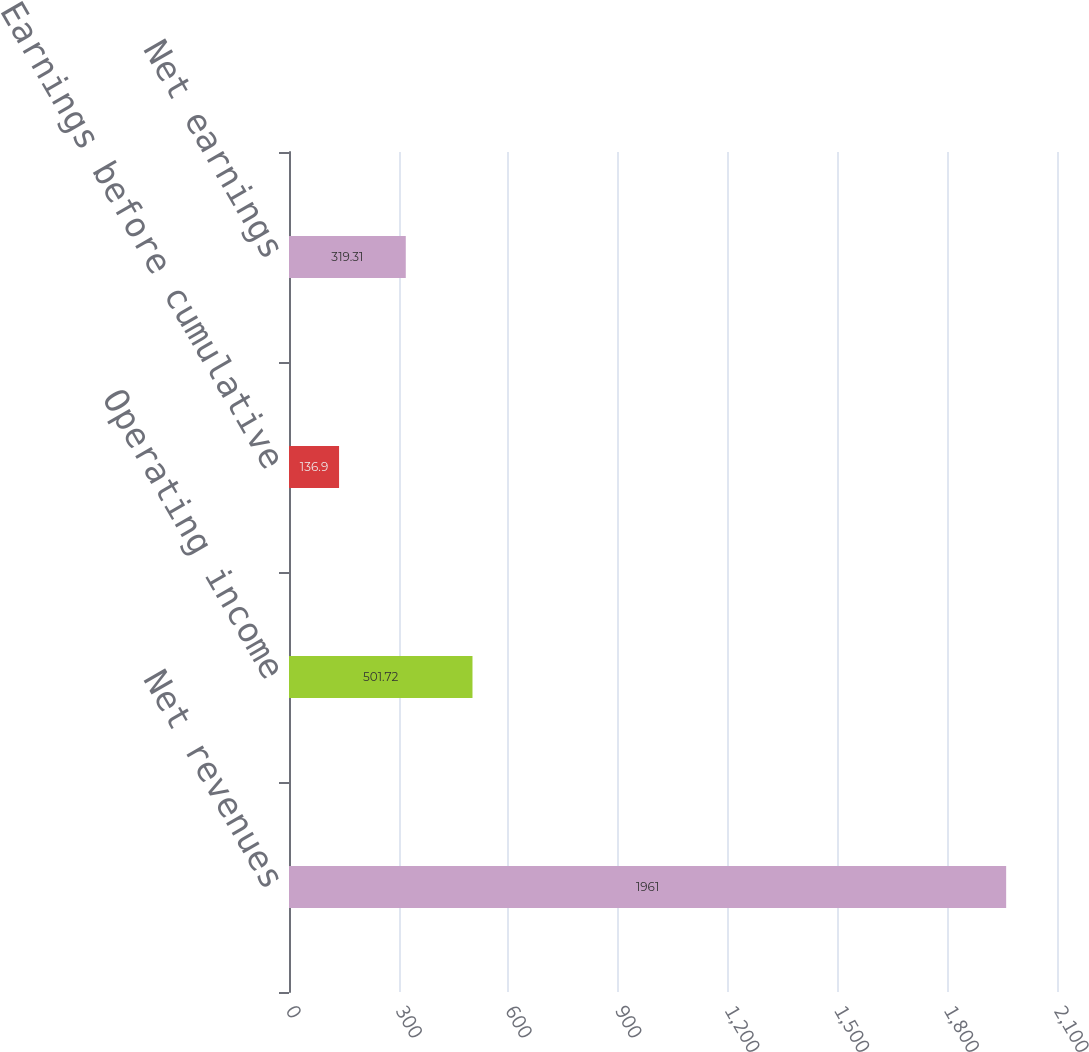Convert chart. <chart><loc_0><loc_0><loc_500><loc_500><bar_chart><fcel>Net revenues<fcel>Operating income<fcel>Earnings before cumulative<fcel>Net earnings<nl><fcel>1961<fcel>501.72<fcel>136.9<fcel>319.31<nl></chart> 